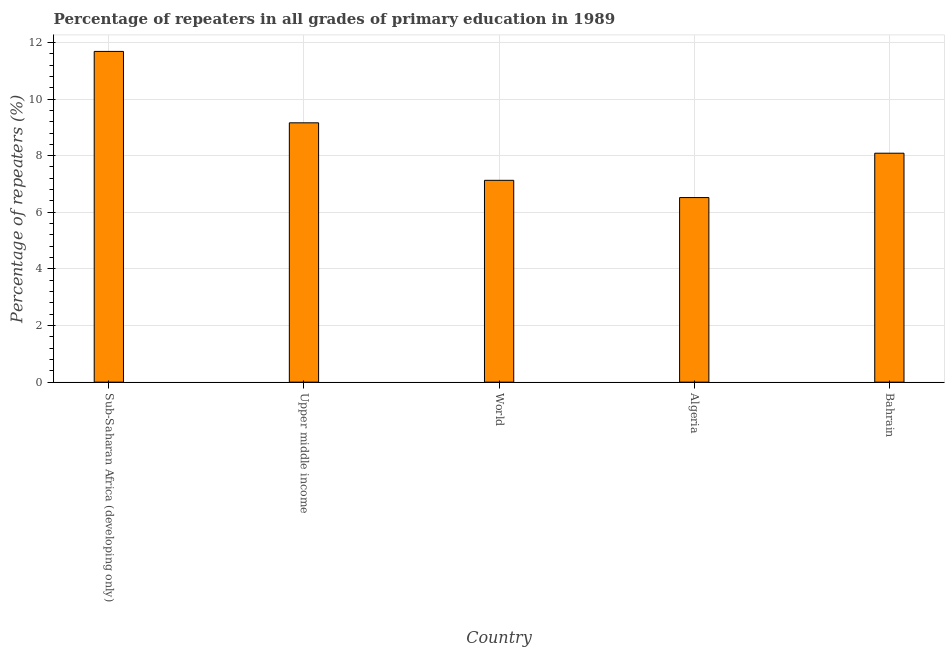Does the graph contain any zero values?
Provide a short and direct response. No. What is the title of the graph?
Give a very brief answer. Percentage of repeaters in all grades of primary education in 1989. What is the label or title of the Y-axis?
Provide a short and direct response. Percentage of repeaters (%). What is the percentage of repeaters in primary education in World?
Provide a succinct answer. 7.13. Across all countries, what is the maximum percentage of repeaters in primary education?
Give a very brief answer. 11.68. Across all countries, what is the minimum percentage of repeaters in primary education?
Keep it short and to the point. 6.52. In which country was the percentage of repeaters in primary education maximum?
Ensure brevity in your answer.  Sub-Saharan Africa (developing only). In which country was the percentage of repeaters in primary education minimum?
Keep it short and to the point. Algeria. What is the sum of the percentage of repeaters in primary education?
Ensure brevity in your answer.  42.58. What is the difference between the percentage of repeaters in primary education in Sub-Saharan Africa (developing only) and Upper middle income?
Provide a succinct answer. 2.52. What is the average percentage of repeaters in primary education per country?
Make the answer very short. 8.52. What is the median percentage of repeaters in primary education?
Give a very brief answer. 8.09. In how many countries, is the percentage of repeaters in primary education greater than 1.6 %?
Ensure brevity in your answer.  5. What is the ratio of the percentage of repeaters in primary education in Bahrain to that in World?
Your answer should be compact. 1.13. Is the percentage of repeaters in primary education in Bahrain less than that in Upper middle income?
Your answer should be very brief. Yes. Is the difference between the percentage of repeaters in primary education in Algeria and Sub-Saharan Africa (developing only) greater than the difference between any two countries?
Offer a very short reply. Yes. What is the difference between the highest and the second highest percentage of repeaters in primary education?
Give a very brief answer. 2.52. What is the difference between the highest and the lowest percentage of repeaters in primary education?
Give a very brief answer. 5.16. In how many countries, is the percentage of repeaters in primary education greater than the average percentage of repeaters in primary education taken over all countries?
Provide a succinct answer. 2. Are all the bars in the graph horizontal?
Offer a very short reply. No. How many countries are there in the graph?
Keep it short and to the point. 5. Are the values on the major ticks of Y-axis written in scientific E-notation?
Make the answer very short. No. What is the Percentage of repeaters (%) in Sub-Saharan Africa (developing only)?
Your response must be concise. 11.68. What is the Percentage of repeaters (%) of Upper middle income?
Give a very brief answer. 9.16. What is the Percentage of repeaters (%) in World?
Ensure brevity in your answer.  7.13. What is the Percentage of repeaters (%) of Algeria?
Offer a terse response. 6.52. What is the Percentage of repeaters (%) of Bahrain?
Your answer should be very brief. 8.09. What is the difference between the Percentage of repeaters (%) in Sub-Saharan Africa (developing only) and Upper middle income?
Give a very brief answer. 2.52. What is the difference between the Percentage of repeaters (%) in Sub-Saharan Africa (developing only) and World?
Offer a very short reply. 4.55. What is the difference between the Percentage of repeaters (%) in Sub-Saharan Africa (developing only) and Algeria?
Make the answer very short. 5.16. What is the difference between the Percentage of repeaters (%) in Sub-Saharan Africa (developing only) and Bahrain?
Your answer should be compact. 3.6. What is the difference between the Percentage of repeaters (%) in Upper middle income and World?
Ensure brevity in your answer.  2.03. What is the difference between the Percentage of repeaters (%) in Upper middle income and Algeria?
Provide a succinct answer. 2.64. What is the difference between the Percentage of repeaters (%) in Upper middle income and Bahrain?
Your response must be concise. 1.07. What is the difference between the Percentage of repeaters (%) in World and Algeria?
Your answer should be very brief. 0.61. What is the difference between the Percentage of repeaters (%) in World and Bahrain?
Provide a short and direct response. -0.96. What is the difference between the Percentage of repeaters (%) in Algeria and Bahrain?
Your answer should be compact. -1.57. What is the ratio of the Percentage of repeaters (%) in Sub-Saharan Africa (developing only) to that in Upper middle income?
Give a very brief answer. 1.27. What is the ratio of the Percentage of repeaters (%) in Sub-Saharan Africa (developing only) to that in World?
Make the answer very short. 1.64. What is the ratio of the Percentage of repeaters (%) in Sub-Saharan Africa (developing only) to that in Algeria?
Your answer should be compact. 1.79. What is the ratio of the Percentage of repeaters (%) in Sub-Saharan Africa (developing only) to that in Bahrain?
Your answer should be very brief. 1.45. What is the ratio of the Percentage of repeaters (%) in Upper middle income to that in World?
Provide a succinct answer. 1.28. What is the ratio of the Percentage of repeaters (%) in Upper middle income to that in Algeria?
Give a very brief answer. 1.41. What is the ratio of the Percentage of repeaters (%) in Upper middle income to that in Bahrain?
Provide a succinct answer. 1.13. What is the ratio of the Percentage of repeaters (%) in World to that in Algeria?
Your response must be concise. 1.09. What is the ratio of the Percentage of repeaters (%) in World to that in Bahrain?
Make the answer very short. 0.88. What is the ratio of the Percentage of repeaters (%) in Algeria to that in Bahrain?
Keep it short and to the point. 0.81. 